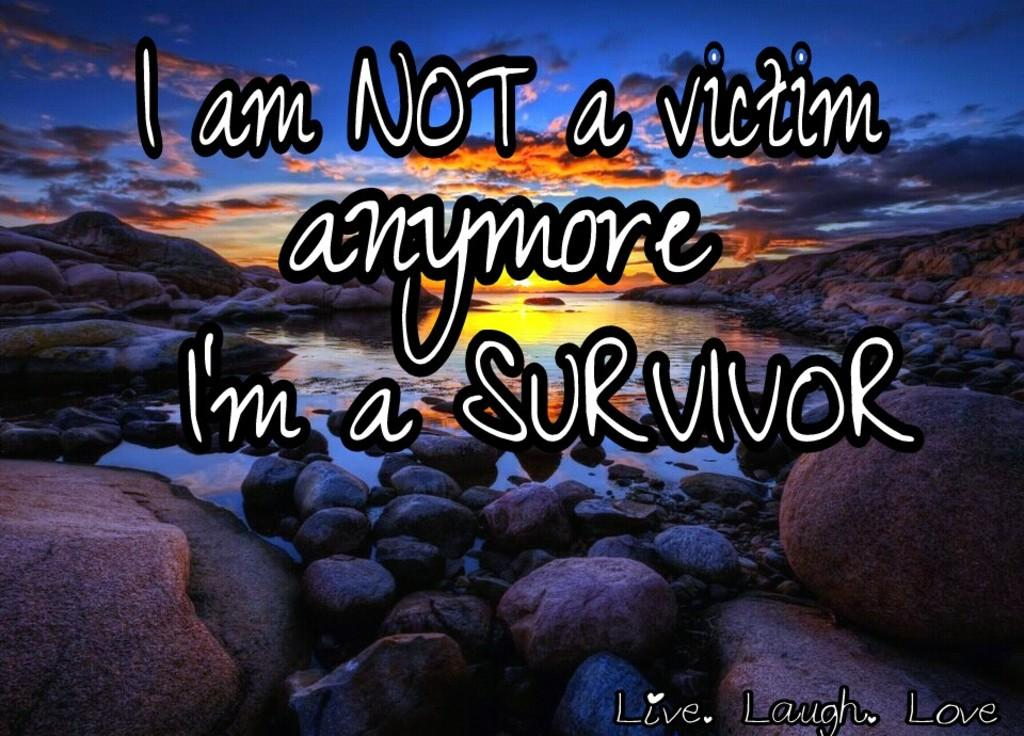<image>
Provide a brief description of the given image. a rock image with a sunset and the word survivor on it 